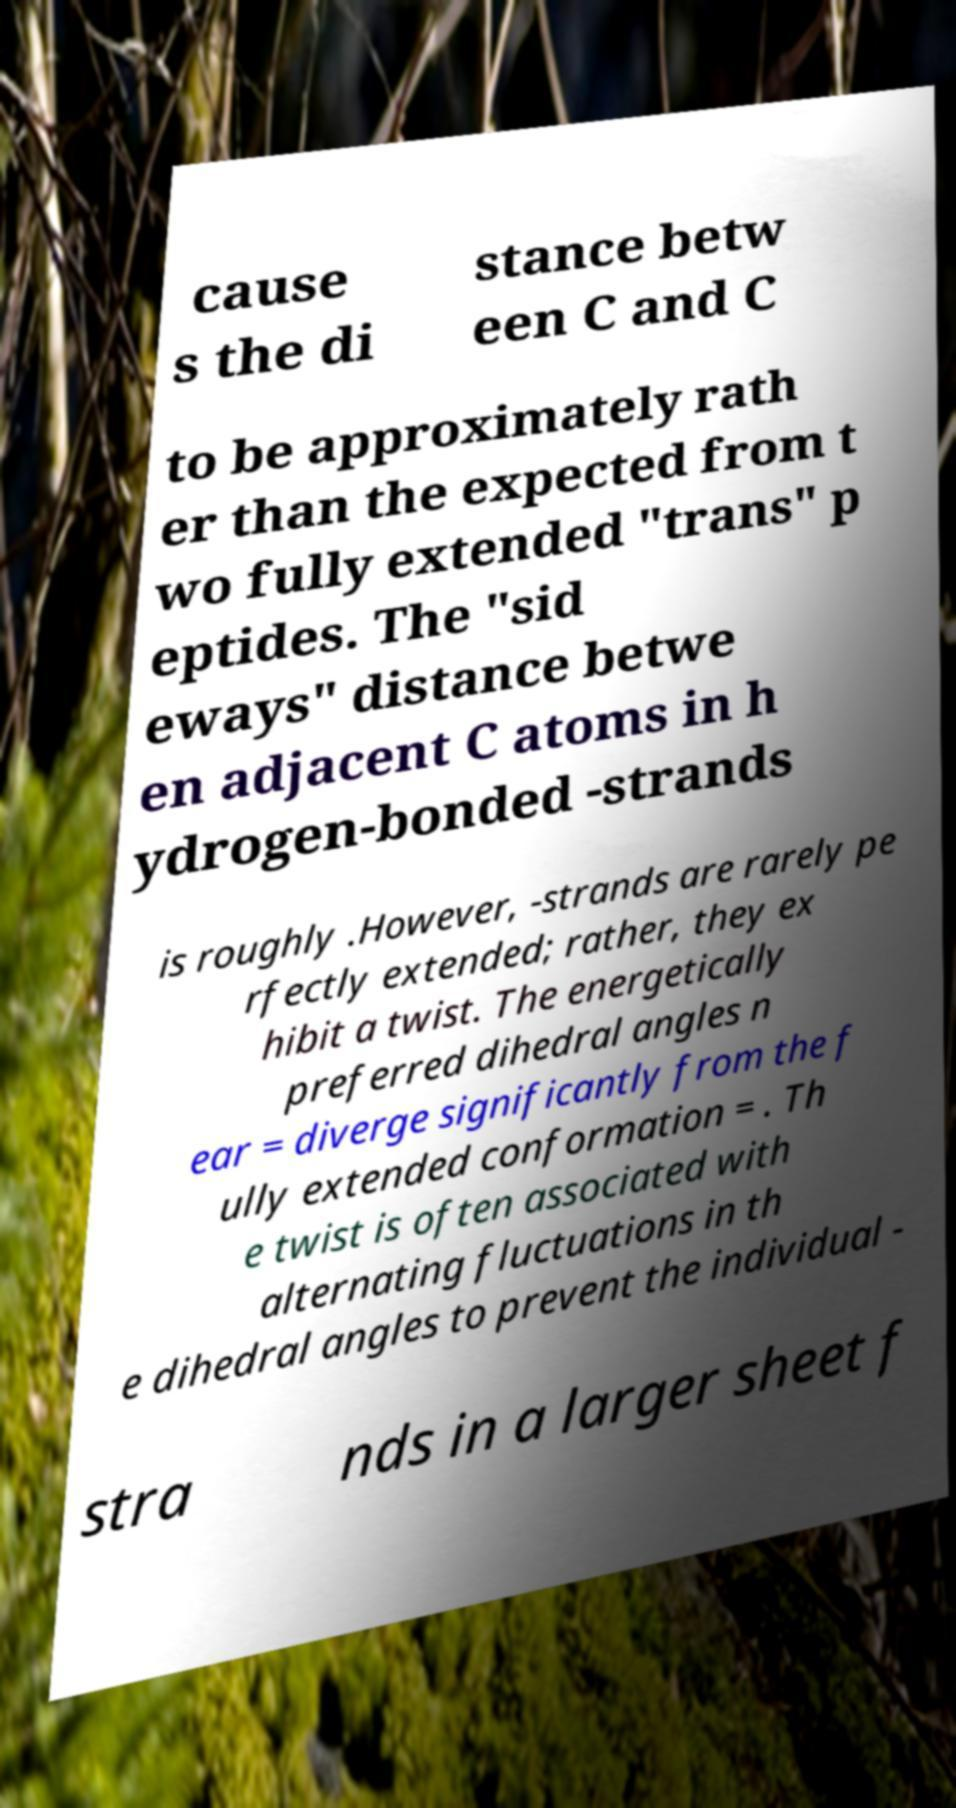For documentation purposes, I need the text within this image transcribed. Could you provide that? cause s the di stance betw een C and C to be approximately rath er than the expected from t wo fully extended "trans" p eptides. The "sid eways" distance betwe en adjacent C atoms in h ydrogen-bonded -strands is roughly .However, -strands are rarely pe rfectly extended; rather, they ex hibit a twist. The energetically preferred dihedral angles n ear = diverge significantly from the f ully extended conformation = . Th e twist is often associated with alternating fluctuations in th e dihedral angles to prevent the individual - stra nds in a larger sheet f 